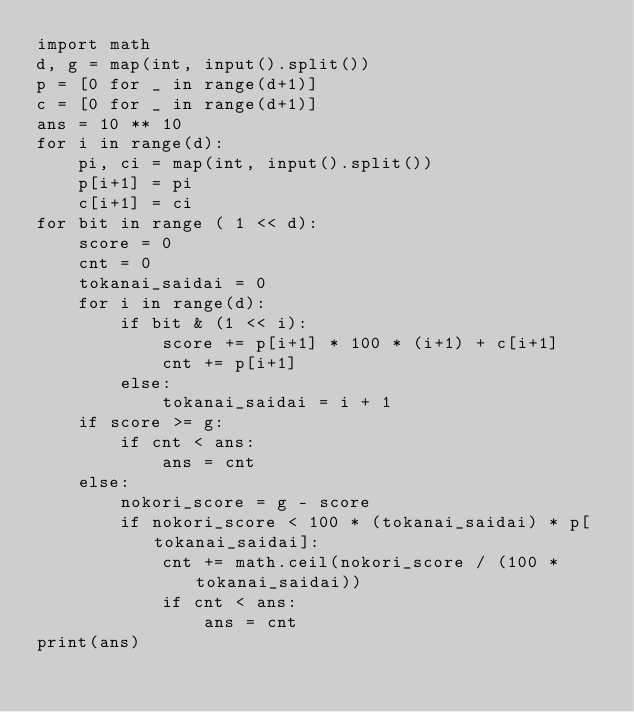<code> <loc_0><loc_0><loc_500><loc_500><_Python_>import math
d, g = map(int, input().split())
p = [0 for _ in range(d+1)]
c = [0 for _ in range(d+1)]
ans = 10 ** 10
for i in range(d):
    pi, ci = map(int, input().split())
    p[i+1] = pi
    c[i+1] = ci     
for bit in range ( 1 << d):
    score = 0
    cnt = 0
    tokanai_saidai = 0
    for i in range(d):
        if bit & (1 << i):
            score += p[i+1] * 100 * (i+1) + c[i+1]
            cnt += p[i+1]
        else:
            tokanai_saidai = i + 1
    if score >= g:
        if cnt < ans:
            ans = cnt
    else:
        nokori_score = g - score
        if nokori_score < 100 * (tokanai_saidai) * p[tokanai_saidai]:
            cnt += math.ceil(nokori_score / (100 * tokanai_saidai))
            if cnt < ans:
                ans = cnt 
print(ans)</code> 